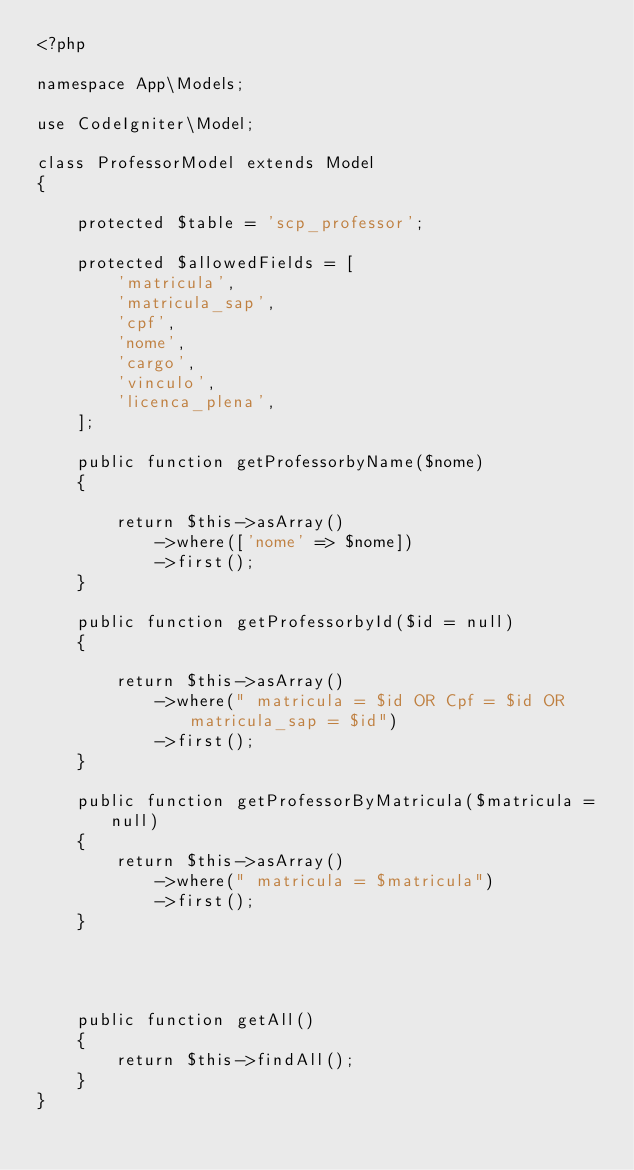<code> <loc_0><loc_0><loc_500><loc_500><_PHP_><?php

namespace App\Models;

use CodeIgniter\Model;

class ProfessorModel extends Model
{

    protected $table = 'scp_professor';

    protected $allowedFields = [
        'matricula',
        'matricula_sap',
        'cpf',
        'nome',
        'cargo',
        'vinculo',
        'licenca_plena',
    ];

    public function getProfessorbyName($nome)
    {

        return $this->asArray()
            ->where(['nome' => $nome])
            ->first();
    }

    public function getProfessorbyId($id = null)
    {

        return $this->asArray()
            ->where(" matricula = $id OR Cpf = $id OR matricula_sap = $id")
            ->first();
    }

    public function getProfessorByMatricula($matricula = null)
    {
        return $this->asArray()
            ->where(" matricula = $matricula")
            ->first();
    }




    public function getAll()
    {
        return $this->findAll();
    }
}
</code> 